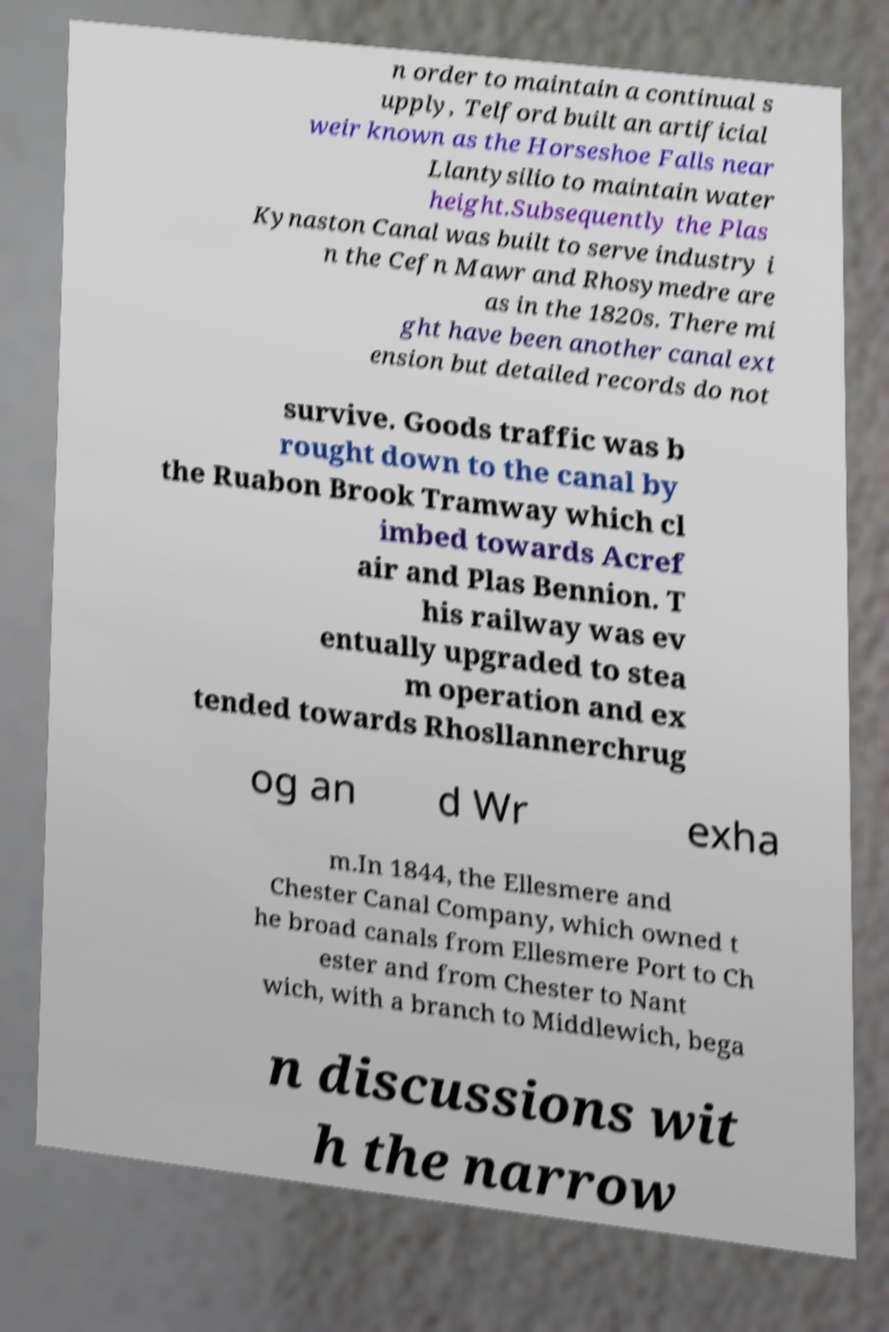Could you extract and type out the text from this image? n order to maintain a continual s upply, Telford built an artificial weir known as the Horseshoe Falls near Llantysilio to maintain water height.Subsequently the Plas Kynaston Canal was built to serve industry i n the Cefn Mawr and Rhosymedre are as in the 1820s. There mi ght have been another canal ext ension but detailed records do not survive. Goods traffic was b rought down to the canal by the Ruabon Brook Tramway which cl imbed towards Acref air and Plas Bennion. T his railway was ev entually upgraded to stea m operation and ex tended towards Rhosllannerchrug og an d Wr exha m.In 1844, the Ellesmere and Chester Canal Company, which owned t he broad canals from Ellesmere Port to Ch ester and from Chester to Nant wich, with a branch to Middlewich, bega n discussions wit h the narrow 